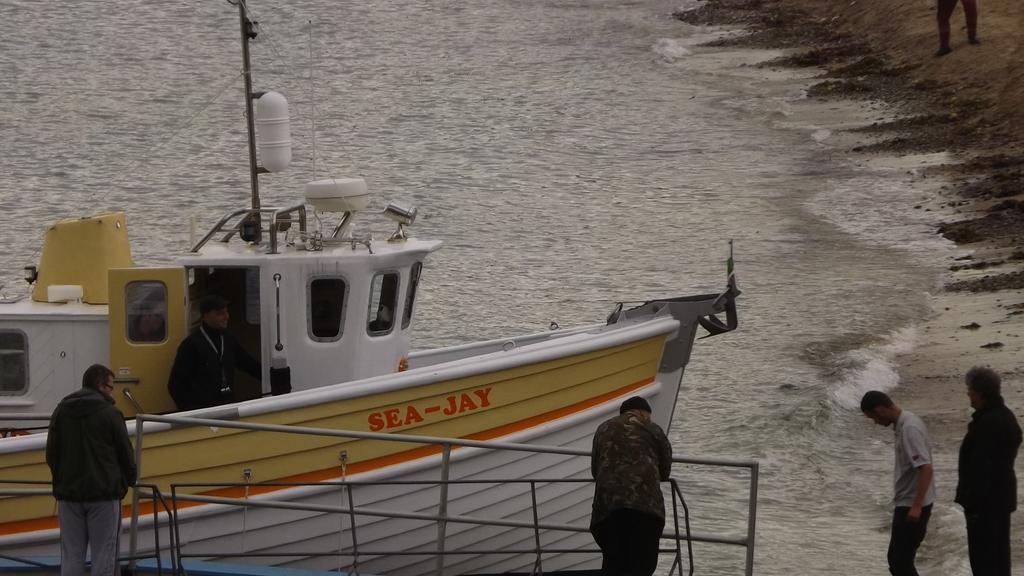In one or two sentences, can you explain what this image depicts? At the bottom of the picture, we see two men are standing. In front of them, we see the iron rods. In the right bottom, we see two men are standing. We see a ship in white and yellow color is sailing on the water. We see a man is riding the ship. In the background, we see water and this water might be in the sea. In the right top, we see the person is standing and we see the sand. 